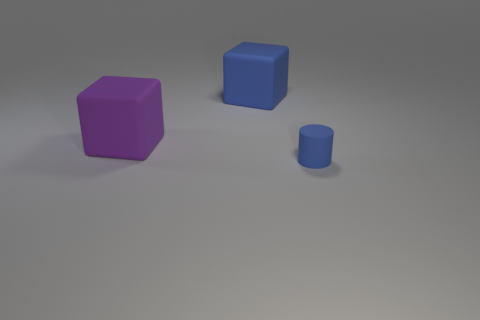Is there any other thing that has the same shape as the small blue object?
Your answer should be very brief. No. Is the number of brown objects greater than the number of large rubber things?
Offer a terse response. No. What color is the big rubber block that is behind the large purple object?
Offer a terse response. Blue. What size is the object that is in front of the blue matte block and left of the blue cylinder?
Make the answer very short. Large. What number of objects have the same size as the blue block?
Make the answer very short. 1. There is a blue object that is the same shape as the purple thing; what material is it?
Make the answer very short. Rubber. Does the large blue matte object have the same shape as the purple object?
Offer a very short reply. Yes. What number of tiny objects are to the right of the tiny rubber cylinder?
Provide a short and direct response. 0. What is the shape of the thing to the left of the big rubber cube that is behind the purple thing?
Provide a short and direct response. Cube. There is another tiny object that is made of the same material as the purple thing; what is its shape?
Your response must be concise. Cylinder. 